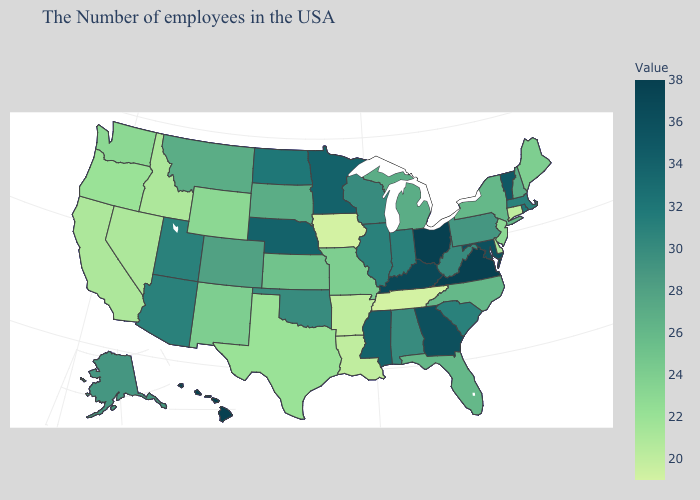Does Montana have the lowest value in the USA?
Answer briefly. No. Does Idaho have the highest value in the West?
Short answer required. No. Does Vermont have the highest value in the Northeast?
Keep it brief. Yes. Does California have a lower value than Rhode Island?
Answer briefly. Yes. Among the states that border Iowa , does Missouri have the lowest value?
Keep it brief. Yes. 